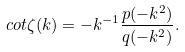<formula> <loc_0><loc_0><loc_500><loc_500>c o t \zeta ( k ) = - k ^ { - 1 } \frac { p ( - k ^ { 2 } ) } { q ( - k ^ { 2 } ) } .</formula> 